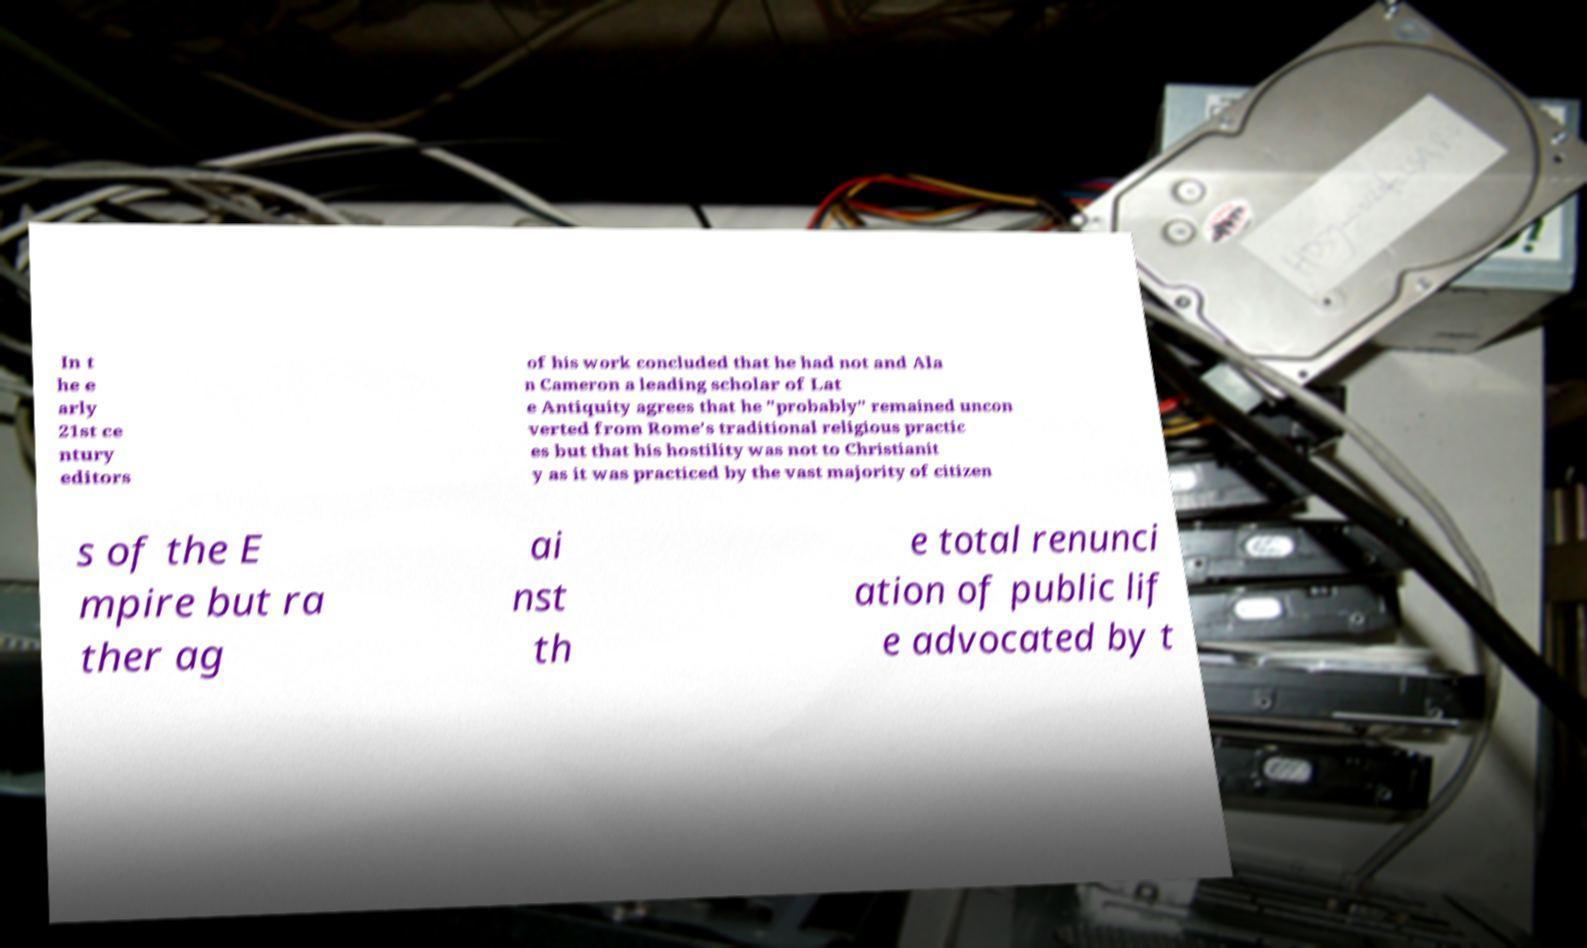Can you read and provide the text displayed in the image?This photo seems to have some interesting text. Can you extract and type it out for me? In t he e arly 21st ce ntury editors of his work concluded that he had not and Ala n Cameron a leading scholar of Lat e Antiquity agrees that he "probably" remained uncon verted from Rome's traditional religious practic es but that his hostility was not to Christianit y as it was practiced by the vast majority of citizen s of the E mpire but ra ther ag ai nst th e total renunci ation of public lif e advocated by t 